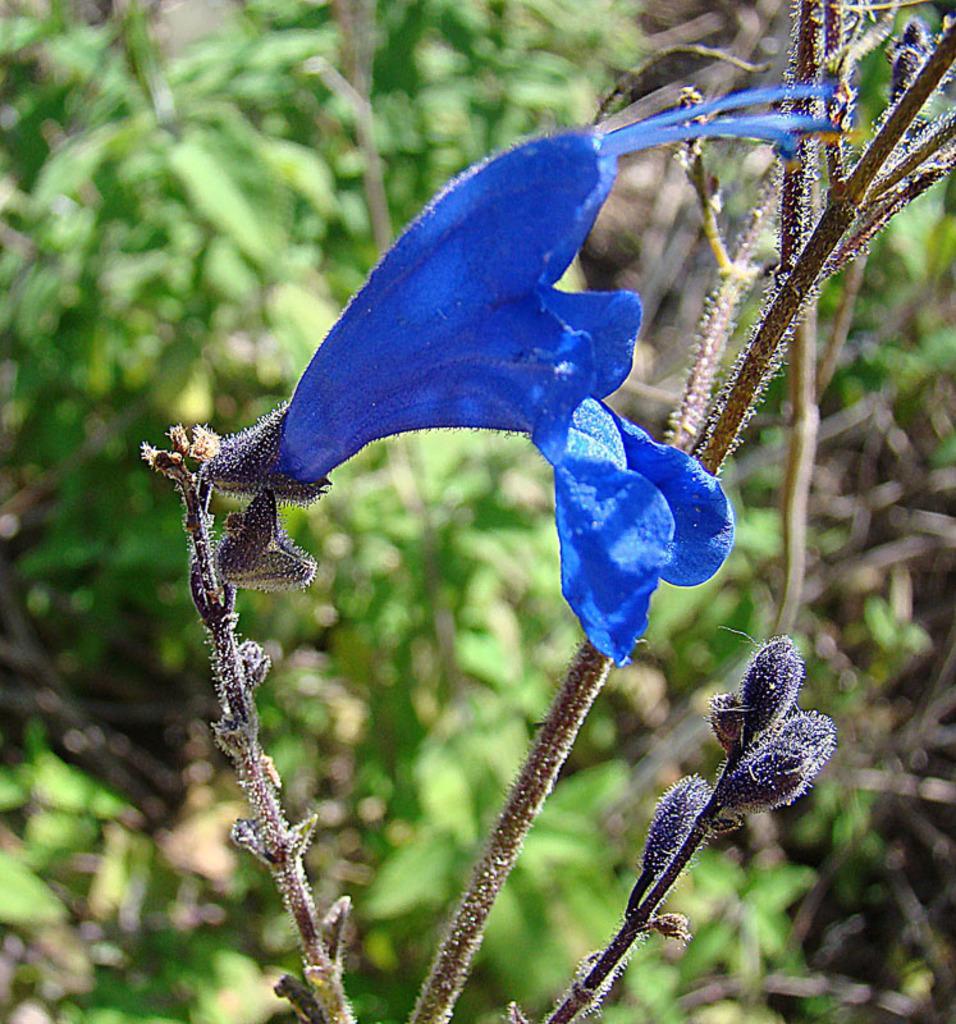Please provide a concise description of this image. In this image we can see flower, plants, and the background is blurred. 